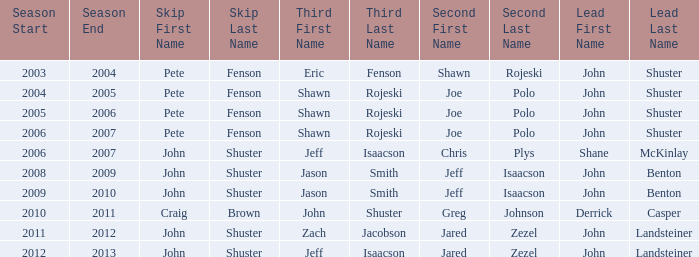Who was the lead with John Shuster as skip, Chris Plys in second, and Jeff Isaacson in third? Shane McKinlay. 